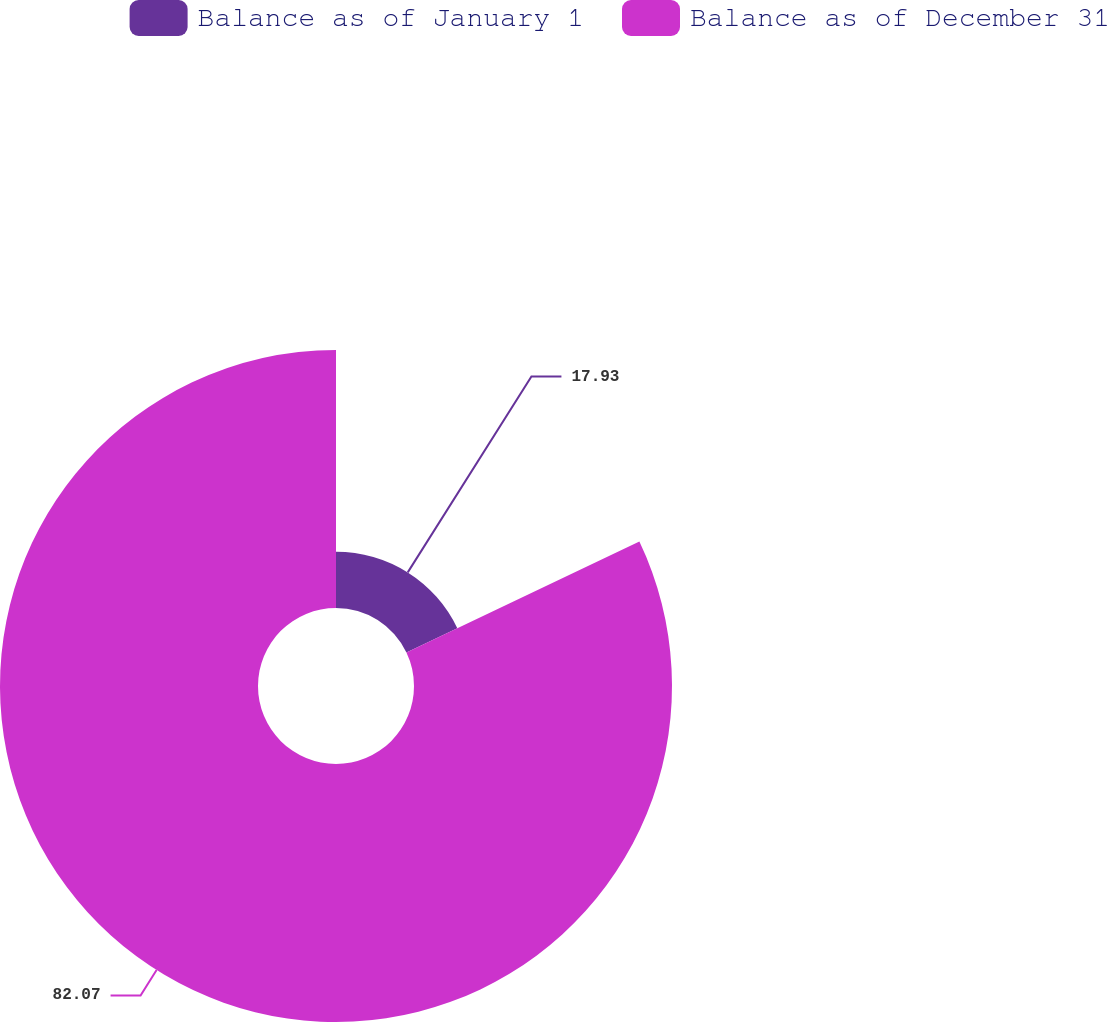Convert chart. <chart><loc_0><loc_0><loc_500><loc_500><pie_chart><fcel>Balance as of January 1<fcel>Balance as of December 31<nl><fcel>17.93%<fcel>82.07%<nl></chart> 